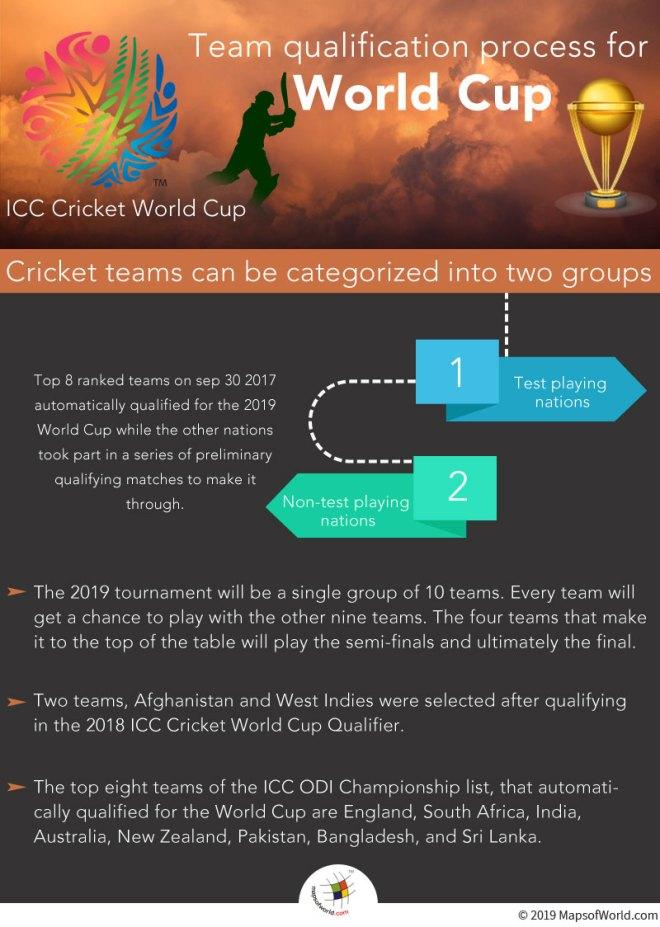Draw attention to some important aspects in this diagram. Cricket is divided into two main categories: Test playing nations and non-Test playing nations, which determine the strength and skill level of the teams involved. 